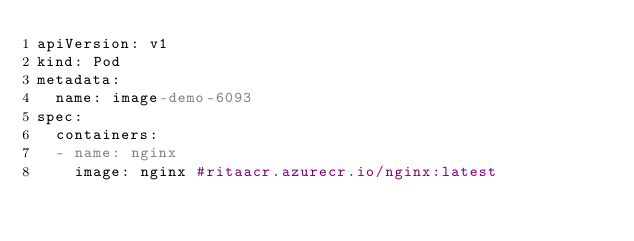<code> <loc_0><loc_0><loc_500><loc_500><_YAML_>apiVersion: v1
kind: Pod
metadata:
  name: image-demo-6093
spec:
  containers:
  - name: nginx
    image: nginx #ritaacr.azurecr.io/nginx:latest</code> 